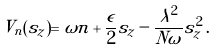Convert formula to latex. <formula><loc_0><loc_0><loc_500><loc_500>V _ { n } ( s _ { z } ) = \omega n + \frac { \epsilon } { 2 } s _ { z } - { \frac { \lambda ^ { 2 } } { N \omega } } s _ { z } ^ { 2 } \, .</formula> 